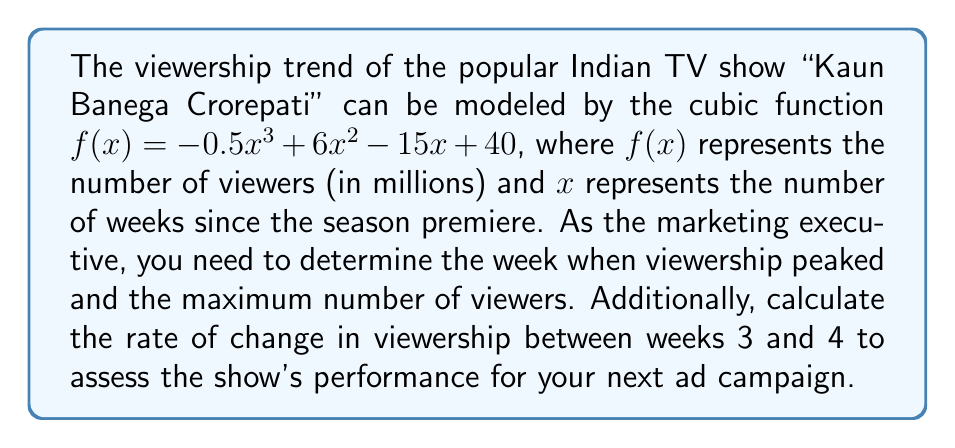Show me your answer to this math problem. To solve this problem, we'll follow these steps:

1. Find the peak viewership:
   a) Calculate the derivative of $f(x)$: $f'(x) = -1.5x^2 + 12x - 15$
   b) Set $f'(x) = 0$ and solve for $x$:
      $-1.5x^2 + 12x - 15 = 0$
      $-3x^2 + 24x - 30 = 0$
      $-3(x^2 - 8x + 10) = 0$
      $-3(x - 5)(x - 3) = 0$
      $x = 5$ or $x = 3$
   c) Check the second derivative $f''(x) = -3x + 12$ at $x = 5$ and $x = 3$:
      $f''(5) = -3(5) + 12 = -3 < 0$ (local maximum)
      $f''(3) = -3(3) + 12 = 3 > 0$ (local minimum)

   The viewership peaked at $x = 5$ weeks after the premiere.

2. Calculate the maximum number of viewers:
   $f(5) = -0.5(5)^3 + 6(5)^2 - 15(5) + 40$
         $= -62.5 + 150 - 75 + 40$
         $= 52.5$ million viewers

3. Calculate the rate of change between weeks 3 and 4:
   Use the average rate of change formula:
   $\frac{f(4) - f(3)}{4 - 3} = f(4) - f(3)$
   
   $f(4) = -0.5(4)^3 + 6(4)^2 - 15(4) + 40 = -32 + 96 - 60 + 40 = 44$
   $f(3) = -0.5(3)^3 + 6(3)^2 - 15(3) + 40 = -13.5 + 54 - 45 + 40 = 35.5$
   
   Rate of change = $44 - 35.5 = 8.5$ million viewers per week
Answer: The viewership peaked at week 5 with 52.5 million viewers. The rate of change in viewership between weeks 3 and 4 was 8.5 million viewers per week. 